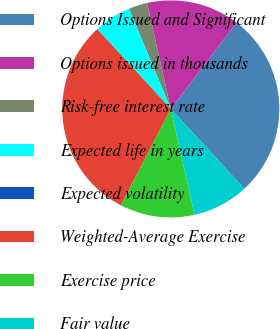<chart> <loc_0><loc_0><loc_500><loc_500><pie_chart><fcel>Options Issued and Significant<fcel>Options issued in thousands<fcel>Risk-free interest rate<fcel>Expected life in years<fcel>Expected volatility<fcel>Weighted-Average Exercise<fcel>Exercise price<fcel>Fair value<nl><fcel>27.77%<fcel>13.89%<fcel>2.78%<fcel>5.56%<fcel>0.01%<fcel>30.55%<fcel>11.11%<fcel>8.34%<nl></chart> 